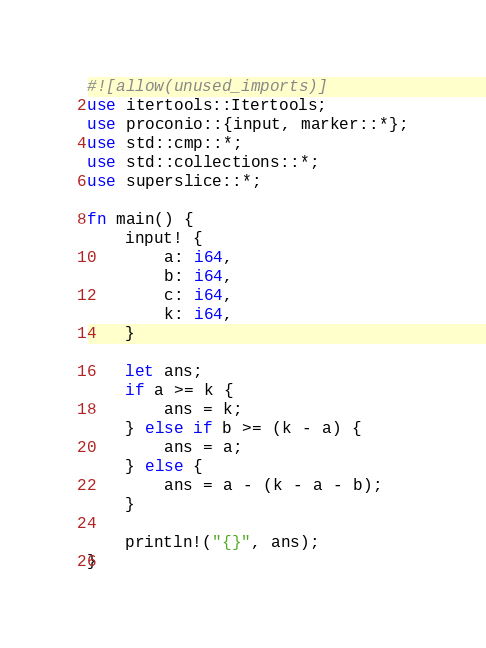<code> <loc_0><loc_0><loc_500><loc_500><_Rust_>#![allow(unused_imports)]
use itertools::Itertools;
use proconio::{input, marker::*};
use std::cmp::*;
use std::collections::*;
use superslice::*;

fn main() {
    input! {
        a: i64,
        b: i64,
        c: i64,
        k: i64,
    }

    let ans;
    if a >= k {
        ans = k;
    } else if b >= (k - a) {
        ans = a;
    } else {
        ans = a - (k - a - b);
    }

    println!("{}", ans);
}
</code> 